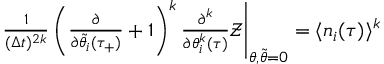Convert formula to latex. <formula><loc_0><loc_0><loc_500><loc_500>\begin{array} { r } { \frac { 1 } { ( \Delta t ) ^ { 2 k } } \left ( \frac { \partial } { \partial \tilde { \theta } _ { i } ( \tau _ { + } ) } + 1 \right ) ^ { k } \frac { \partial ^ { k } } { \partial \theta _ { i } ^ { k } ( \tau ) } \mathcal { Z } \Big | _ { \theta , \tilde { \theta } = 0 } = \langle n _ { i } ( \tau ) \rangle ^ { k } } \end{array}</formula> 